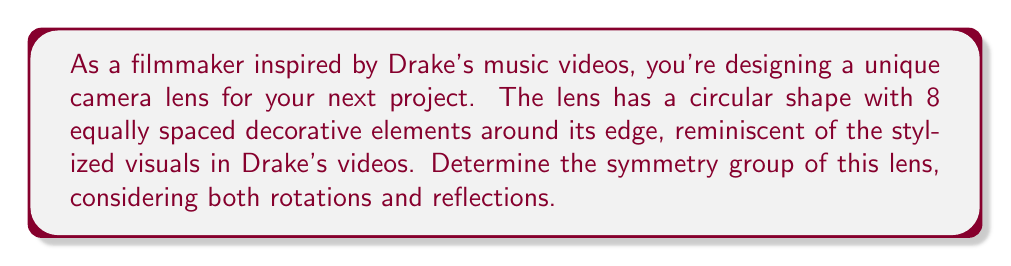What is the answer to this math problem? Let's approach this step-by-step:

1) First, we need to identify the symmetries of the lens:

   a) Rotational symmetries: The lens can be rotated by multiples of 45° (360°/8) and still look the same. This gives us 8 rotational symmetries (including the identity rotation of 0°).

   b) Reflection symmetries: There are 8 lines of reflection - 4 passing through opposite decorative elements and 4 passing between adjacent elements.

2) The symmetry group of this lens is the dihedral group $D_8$, which has order 16.

3) The elements of $D_8$ can be represented as:
   
   $$D_8 = \{e, r, r^2, r^3, r^4, r^5, r^6, r^7, s, sr, sr^2, sr^3, sr^4, sr^5, sr^6, sr^7\}$$

   Where $e$ is the identity, $r$ represents a rotation of 45°, and $s$ represents a reflection.

4) The group operation table for $D_8$ would be a 16x16 table.

5) The group has the following properties:
   - It is non-abelian (rotations and reflections don't always commute)
   - It has 16 elements
   - Its subgroups include $C_8$ (the cyclic group of order 8) and several $C_2$ groups

6) In the context of filmmaking, understanding this symmetry group could help in creating visually balanced shots or in designing transitions that utilize the symmetrical properties of the lens.
Answer: The symmetry group of the camera lens is the dihedral group $D_8$, which has order 16 and includes 8 rotational symmetries and 8 reflection symmetries. 